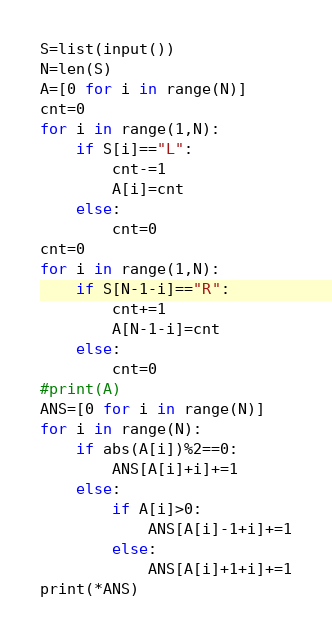<code> <loc_0><loc_0><loc_500><loc_500><_Python_>S=list(input())
N=len(S)
A=[0 for i in range(N)]
cnt=0
for i in range(1,N):
    if S[i]=="L":
        cnt-=1
        A[i]=cnt
    else:
        cnt=0
cnt=0
for i in range(1,N):
    if S[N-1-i]=="R":
        cnt+=1
        A[N-1-i]=cnt
    else:
        cnt=0
#print(A)
ANS=[0 for i in range(N)]
for i in range(N):
    if abs(A[i])%2==0:
        ANS[A[i]+i]+=1
    else:
        if A[i]>0:
            ANS[A[i]-1+i]+=1
        else:
            ANS[A[i]+1+i]+=1
print(*ANS)</code> 